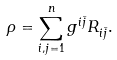<formula> <loc_0><loc_0><loc_500><loc_500>\rho = \sum _ { i , j = 1 } ^ { n } g ^ { i \bar { j } } R _ { i \bar { j } } .</formula> 